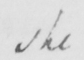What text is written in this handwritten line? she 